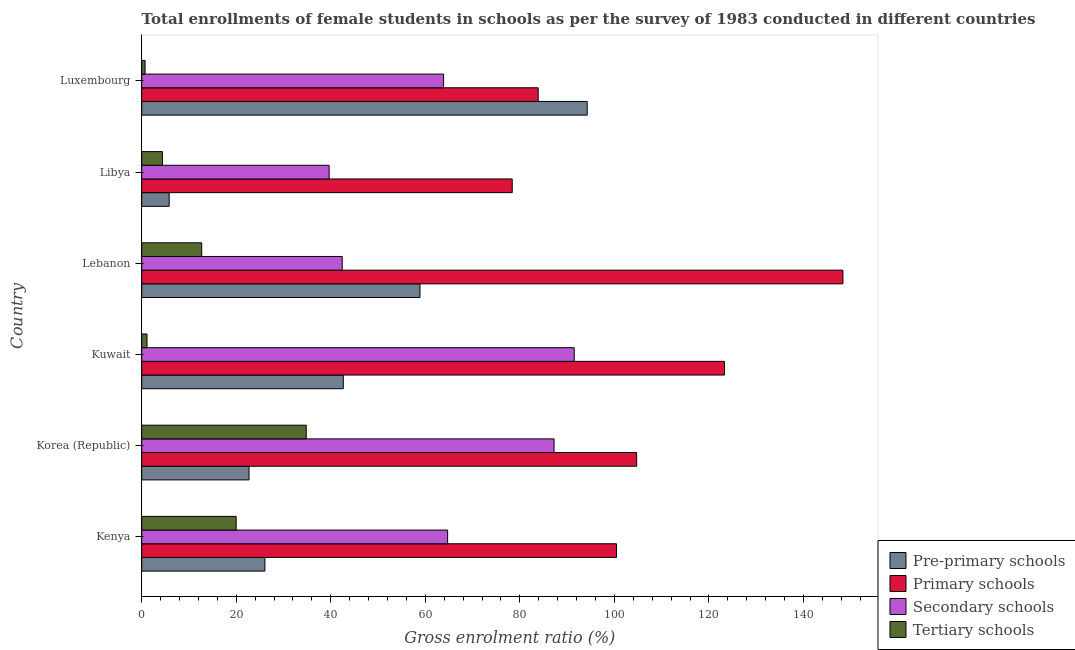How many groups of bars are there?
Your response must be concise. 6. Are the number of bars on each tick of the Y-axis equal?
Provide a short and direct response. Yes. How many bars are there on the 3rd tick from the top?
Keep it short and to the point. 4. What is the label of the 4th group of bars from the top?
Give a very brief answer. Kuwait. What is the gross enrolment ratio(female) in tertiary schools in Lebanon?
Your response must be concise. 12.69. Across all countries, what is the maximum gross enrolment ratio(female) in primary schools?
Provide a succinct answer. 148.33. Across all countries, what is the minimum gross enrolment ratio(female) in secondary schools?
Offer a terse response. 39.65. In which country was the gross enrolment ratio(female) in tertiary schools maximum?
Make the answer very short. Korea (Republic). In which country was the gross enrolment ratio(female) in primary schools minimum?
Ensure brevity in your answer.  Libya. What is the total gross enrolment ratio(female) in tertiary schools in the graph?
Your answer should be very brief. 73.69. What is the difference between the gross enrolment ratio(female) in primary schools in Korea (Republic) and that in Lebanon?
Ensure brevity in your answer.  -43.64. What is the difference between the gross enrolment ratio(female) in primary schools in Luxembourg and the gross enrolment ratio(female) in pre-primary schools in Kuwait?
Make the answer very short. 41.22. What is the average gross enrolment ratio(female) in pre-primary schools per country?
Make the answer very short. 41.72. What is the difference between the gross enrolment ratio(female) in pre-primary schools and gross enrolment ratio(female) in tertiary schools in Libya?
Give a very brief answer. 1.43. In how many countries, is the gross enrolment ratio(female) in primary schools greater than 120 %?
Make the answer very short. 2. What is the ratio of the gross enrolment ratio(female) in pre-primary schools in Kenya to that in Libya?
Provide a short and direct response. 4.49. Is the difference between the gross enrolment ratio(female) in tertiary schools in Kenya and Lebanon greater than the difference between the gross enrolment ratio(female) in pre-primary schools in Kenya and Lebanon?
Provide a succinct answer. Yes. What is the difference between the highest and the second highest gross enrolment ratio(female) in pre-primary schools?
Give a very brief answer. 35.38. What is the difference between the highest and the lowest gross enrolment ratio(female) in primary schools?
Offer a very short reply. 69.95. Is the sum of the gross enrolment ratio(female) in tertiary schools in Kuwait and Luxembourg greater than the maximum gross enrolment ratio(female) in pre-primary schools across all countries?
Make the answer very short. No. Is it the case that in every country, the sum of the gross enrolment ratio(female) in secondary schools and gross enrolment ratio(female) in pre-primary schools is greater than the sum of gross enrolment ratio(female) in primary schools and gross enrolment ratio(female) in tertiary schools?
Ensure brevity in your answer.  No. What does the 2nd bar from the top in Libya represents?
Your answer should be very brief. Secondary schools. What does the 2nd bar from the bottom in Luxembourg represents?
Give a very brief answer. Primary schools. Are all the bars in the graph horizontal?
Make the answer very short. Yes. Are the values on the major ticks of X-axis written in scientific E-notation?
Make the answer very short. No. How are the legend labels stacked?
Provide a short and direct response. Vertical. What is the title of the graph?
Your response must be concise. Total enrollments of female students in schools as per the survey of 1983 conducted in different countries. Does "PFC gas" appear as one of the legend labels in the graph?
Your response must be concise. No. What is the label or title of the X-axis?
Your answer should be very brief. Gross enrolment ratio (%). What is the Gross enrolment ratio (%) in Pre-primary schools in Kenya?
Your answer should be compact. 26.06. What is the Gross enrolment ratio (%) in Primary schools in Kenya?
Make the answer very short. 100.43. What is the Gross enrolment ratio (%) in Secondary schools in Kenya?
Ensure brevity in your answer.  64.71. What is the Gross enrolment ratio (%) of Tertiary schools in Kenya?
Ensure brevity in your answer.  19.98. What is the Gross enrolment ratio (%) in Pre-primary schools in Korea (Republic)?
Your response must be concise. 22.7. What is the Gross enrolment ratio (%) in Primary schools in Korea (Republic)?
Offer a terse response. 104.7. What is the Gross enrolment ratio (%) in Secondary schools in Korea (Republic)?
Offer a terse response. 87.23. What is the Gross enrolment ratio (%) of Tertiary schools in Korea (Republic)?
Give a very brief answer. 34.81. What is the Gross enrolment ratio (%) of Pre-primary schools in Kuwait?
Provide a succinct answer. 42.64. What is the Gross enrolment ratio (%) of Primary schools in Kuwait?
Offer a terse response. 123.27. What is the Gross enrolment ratio (%) in Secondary schools in Kuwait?
Provide a succinct answer. 91.49. What is the Gross enrolment ratio (%) in Tertiary schools in Kuwait?
Your response must be concise. 1.12. What is the Gross enrolment ratio (%) of Pre-primary schools in Lebanon?
Your response must be concise. 58.86. What is the Gross enrolment ratio (%) in Primary schools in Lebanon?
Provide a succinct answer. 148.33. What is the Gross enrolment ratio (%) of Secondary schools in Lebanon?
Offer a very short reply. 42.41. What is the Gross enrolment ratio (%) of Tertiary schools in Lebanon?
Give a very brief answer. 12.69. What is the Gross enrolment ratio (%) of Pre-primary schools in Libya?
Give a very brief answer. 5.81. What is the Gross enrolment ratio (%) of Primary schools in Libya?
Your answer should be very brief. 78.38. What is the Gross enrolment ratio (%) of Secondary schools in Libya?
Your response must be concise. 39.65. What is the Gross enrolment ratio (%) of Tertiary schools in Libya?
Your response must be concise. 4.38. What is the Gross enrolment ratio (%) in Pre-primary schools in Luxembourg?
Offer a very short reply. 94.24. What is the Gross enrolment ratio (%) of Primary schools in Luxembourg?
Your response must be concise. 83.87. What is the Gross enrolment ratio (%) in Secondary schools in Luxembourg?
Offer a very short reply. 63.86. What is the Gross enrolment ratio (%) of Tertiary schools in Luxembourg?
Keep it short and to the point. 0.71. Across all countries, what is the maximum Gross enrolment ratio (%) of Pre-primary schools?
Your answer should be very brief. 94.24. Across all countries, what is the maximum Gross enrolment ratio (%) of Primary schools?
Your answer should be very brief. 148.33. Across all countries, what is the maximum Gross enrolment ratio (%) in Secondary schools?
Offer a very short reply. 91.49. Across all countries, what is the maximum Gross enrolment ratio (%) in Tertiary schools?
Provide a succinct answer. 34.81. Across all countries, what is the minimum Gross enrolment ratio (%) of Pre-primary schools?
Give a very brief answer. 5.81. Across all countries, what is the minimum Gross enrolment ratio (%) in Primary schools?
Offer a very short reply. 78.38. Across all countries, what is the minimum Gross enrolment ratio (%) in Secondary schools?
Your response must be concise. 39.65. Across all countries, what is the minimum Gross enrolment ratio (%) of Tertiary schools?
Your answer should be compact. 0.71. What is the total Gross enrolment ratio (%) in Pre-primary schools in the graph?
Your answer should be compact. 250.31. What is the total Gross enrolment ratio (%) of Primary schools in the graph?
Your response must be concise. 638.98. What is the total Gross enrolment ratio (%) in Secondary schools in the graph?
Your answer should be compact. 389.35. What is the total Gross enrolment ratio (%) of Tertiary schools in the graph?
Your answer should be very brief. 73.69. What is the difference between the Gross enrolment ratio (%) in Pre-primary schools in Kenya and that in Korea (Republic)?
Offer a terse response. 3.36. What is the difference between the Gross enrolment ratio (%) of Primary schools in Kenya and that in Korea (Republic)?
Your answer should be very brief. -4.26. What is the difference between the Gross enrolment ratio (%) in Secondary schools in Kenya and that in Korea (Republic)?
Give a very brief answer. -22.52. What is the difference between the Gross enrolment ratio (%) in Tertiary schools in Kenya and that in Korea (Republic)?
Your answer should be compact. -14.83. What is the difference between the Gross enrolment ratio (%) in Pre-primary schools in Kenya and that in Kuwait?
Provide a succinct answer. -16.58. What is the difference between the Gross enrolment ratio (%) in Primary schools in Kenya and that in Kuwait?
Offer a very short reply. -22.84. What is the difference between the Gross enrolment ratio (%) in Secondary schools in Kenya and that in Kuwait?
Provide a short and direct response. -26.78. What is the difference between the Gross enrolment ratio (%) in Tertiary schools in Kenya and that in Kuwait?
Give a very brief answer. 18.86. What is the difference between the Gross enrolment ratio (%) of Pre-primary schools in Kenya and that in Lebanon?
Your response must be concise. -32.8. What is the difference between the Gross enrolment ratio (%) in Primary schools in Kenya and that in Lebanon?
Your answer should be very brief. -47.9. What is the difference between the Gross enrolment ratio (%) in Secondary schools in Kenya and that in Lebanon?
Offer a very short reply. 22.3. What is the difference between the Gross enrolment ratio (%) of Tertiary schools in Kenya and that in Lebanon?
Keep it short and to the point. 7.29. What is the difference between the Gross enrolment ratio (%) in Pre-primary schools in Kenya and that in Libya?
Offer a terse response. 20.25. What is the difference between the Gross enrolment ratio (%) of Primary schools in Kenya and that in Libya?
Keep it short and to the point. 22.05. What is the difference between the Gross enrolment ratio (%) in Secondary schools in Kenya and that in Libya?
Offer a very short reply. 25.06. What is the difference between the Gross enrolment ratio (%) of Tertiary schools in Kenya and that in Libya?
Keep it short and to the point. 15.6. What is the difference between the Gross enrolment ratio (%) of Pre-primary schools in Kenya and that in Luxembourg?
Your answer should be very brief. -68.18. What is the difference between the Gross enrolment ratio (%) in Primary schools in Kenya and that in Luxembourg?
Ensure brevity in your answer.  16.57. What is the difference between the Gross enrolment ratio (%) of Secondary schools in Kenya and that in Luxembourg?
Keep it short and to the point. 0.85. What is the difference between the Gross enrolment ratio (%) in Tertiary schools in Kenya and that in Luxembourg?
Make the answer very short. 19.27. What is the difference between the Gross enrolment ratio (%) in Pre-primary schools in Korea (Republic) and that in Kuwait?
Make the answer very short. -19.94. What is the difference between the Gross enrolment ratio (%) in Primary schools in Korea (Republic) and that in Kuwait?
Make the answer very short. -18.58. What is the difference between the Gross enrolment ratio (%) in Secondary schools in Korea (Republic) and that in Kuwait?
Keep it short and to the point. -4.26. What is the difference between the Gross enrolment ratio (%) in Tertiary schools in Korea (Republic) and that in Kuwait?
Offer a very short reply. 33.69. What is the difference between the Gross enrolment ratio (%) in Pre-primary schools in Korea (Republic) and that in Lebanon?
Keep it short and to the point. -36.16. What is the difference between the Gross enrolment ratio (%) of Primary schools in Korea (Republic) and that in Lebanon?
Give a very brief answer. -43.64. What is the difference between the Gross enrolment ratio (%) of Secondary schools in Korea (Republic) and that in Lebanon?
Make the answer very short. 44.81. What is the difference between the Gross enrolment ratio (%) in Tertiary schools in Korea (Republic) and that in Lebanon?
Offer a terse response. 22.11. What is the difference between the Gross enrolment ratio (%) in Pre-primary schools in Korea (Republic) and that in Libya?
Keep it short and to the point. 16.89. What is the difference between the Gross enrolment ratio (%) of Primary schools in Korea (Republic) and that in Libya?
Offer a very short reply. 26.32. What is the difference between the Gross enrolment ratio (%) in Secondary schools in Korea (Republic) and that in Libya?
Your answer should be compact. 47.58. What is the difference between the Gross enrolment ratio (%) of Tertiary schools in Korea (Republic) and that in Libya?
Give a very brief answer. 30.42. What is the difference between the Gross enrolment ratio (%) in Pre-primary schools in Korea (Republic) and that in Luxembourg?
Give a very brief answer. -71.54. What is the difference between the Gross enrolment ratio (%) in Primary schools in Korea (Republic) and that in Luxembourg?
Ensure brevity in your answer.  20.83. What is the difference between the Gross enrolment ratio (%) of Secondary schools in Korea (Republic) and that in Luxembourg?
Provide a succinct answer. 23.37. What is the difference between the Gross enrolment ratio (%) of Tertiary schools in Korea (Republic) and that in Luxembourg?
Give a very brief answer. 34.09. What is the difference between the Gross enrolment ratio (%) in Pre-primary schools in Kuwait and that in Lebanon?
Your response must be concise. -16.22. What is the difference between the Gross enrolment ratio (%) of Primary schools in Kuwait and that in Lebanon?
Give a very brief answer. -25.06. What is the difference between the Gross enrolment ratio (%) of Secondary schools in Kuwait and that in Lebanon?
Make the answer very short. 49.08. What is the difference between the Gross enrolment ratio (%) of Tertiary schools in Kuwait and that in Lebanon?
Provide a short and direct response. -11.57. What is the difference between the Gross enrolment ratio (%) of Pre-primary schools in Kuwait and that in Libya?
Your response must be concise. 36.83. What is the difference between the Gross enrolment ratio (%) in Primary schools in Kuwait and that in Libya?
Offer a terse response. 44.9. What is the difference between the Gross enrolment ratio (%) in Secondary schools in Kuwait and that in Libya?
Your answer should be very brief. 51.85. What is the difference between the Gross enrolment ratio (%) of Tertiary schools in Kuwait and that in Libya?
Make the answer very short. -3.27. What is the difference between the Gross enrolment ratio (%) in Pre-primary schools in Kuwait and that in Luxembourg?
Your answer should be compact. -51.6. What is the difference between the Gross enrolment ratio (%) in Primary schools in Kuwait and that in Luxembourg?
Your response must be concise. 39.41. What is the difference between the Gross enrolment ratio (%) of Secondary schools in Kuwait and that in Luxembourg?
Your response must be concise. 27.63. What is the difference between the Gross enrolment ratio (%) of Tertiary schools in Kuwait and that in Luxembourg?
Your response must be concise. 0.4. What is the difference between the Gross enrolment ratio (%) in Pre-primary schools in Lebanon and that in Libya?
Offer a very short reply. 53.05. What is the difference between the Gross enrolment ratio (%) of Primary schools in Lebanon and that in Libya?
Your response must be concise. 69.95. What is the difference between the Gross enrolment ratio (%) in Secondary schools in Lebanon and that in Libya?
Ensure brevity in your answer.  2.77. What is the difference between the Gross enrolment ratio (%) of Tertiary schools in Lebanon and that in Libya?
Offer a terse response. 8.31. What is the difference between the Gross enrolment ratio (%) of Pre-primary schools in Lebanon and that in Luxembourg?
Provide a succinct answer. -35.38. What is the difference between the Gross enrolment ratio (%) in Primary schools in Lebanon and that in Luxembourg?
Ensure brevity in your answer.  64.47. What is the difference between the Gross enrolment ratio (%) of Secondary schools in Lebanon and that in Luxembourg?
Provide a succinct answer. -21.44. What is the difference between the Gross enrolment ratio (%) of Tertiary schools in Lebanon and that in Luxembourg?
Give a very brief answer. 11.98. What is the difference between the Gross enrolment ratio (%) of Pre-primary schools in Libya and that in Luxembourg?
Your response must be concise. -88.43. What is the difference between the Gross enrolment ratio (%) in Primary schools in Libya and that in Luxembourg?
Make the answer very short. -5.49. What is the difference between the Gross enrolment ratio (%) in Secondary schools in Libya and that in Luxembourg?
Give a very brief answer. -24.21. What is the difference between the Gross enrolment ratio (%) in Tertiary schools in Libya and that in Luxembourg?
Provide a short and direct response. 3.67. What is the difference between the Gross enrolment ratio (%) of Pre-primary schools in Kenya and the Gross enrolment ratio (%) of Primary schools in Korea (Republic)?
Your answer should be very brief. -78.64. What is the difference between the Gross enrolment ratio (%) of Pre-primary schools in Kenya and the Gross enrolment ratio (%) of Secondary schools in Korea (Republic)?
Provide a succinct answer. -61.17. What is the difference between the Gross enrolment ratio (%) in Pre-primary schools in Kenya and the Gross enrolment ratio (%) in Tertiary schools in Korea (Republic)?
Your answer should be very brief. -8.75. What is the difference between the Gross enrolment ratio (%) of Primary schools in Kenya and the Gross enrolment ratio (%) of Secondary schools in Korea (Republic)?
Provide a short and direct response. 13.2. What is the difference between the Gross enrolment ratio (%) in Primary schools in Kenya and the Gross enrolment ratio (%) in Tertiary schools in Korea (Republic)?
Provide a short and direct response. 65.63. What is the difference between the Gross enrolment ratio (%) of Secondary schools in Kenya and the Gross enrolment ratio (%) of Tertiary schools in Korea (Republic)?
Your answer should be very brief. 29.9. What is the difference between the Gross enrolment ratio (%) of Pre-primary schools in Kenya and the Gross enrolment ratio (%) of Primary schools in Kuwait?
Provide a short and direct response. -97.22. What is the difference between the Gross enrolment ratio (%) of Pre-primary schools in Kenya and the Gross enrolment ratio (%) of Secondary schools in Kuwait?
Keep it short and to the point. -65.44. What is the difference between the Gross enrolment ratio (%) in Pre-primary schools in Kenya and the Gross enrolment ratio (%) in Tertiary schools in Kuwait?
Provide a succinct answer. 24.94. What is the difference between the Gross enrolment ratio (%) of Primary schools in Kenya and the Gross enrolment ratio (%) of Secondary schools in Kuwait?
Provide a short and direct response. 8.94. What is the difference between the Gross enrolment ratio (%) of Primary schools in Kenya and the Gross enrolment ratio (%) of Tertiary schools in Kuwait?
Make the answer very short. 99.32. What is the difference between the Gross enrolment ratio (%) of Secondary schools in Kenya and the Gross enrolment ratio (%) of Tertiary schools in Kuwait?
Your answer should be compact. 63.59. What is the difference between the Gross enrolment ratio (%) of Pre-primary schools in Kenya and the Gross enrolment ratio (%) of Primary schools in Lebanon?
Offer a very short reply. -122.28. What is the difference between the Gross enrolment ratio (%) of Pre-primary schools in Kenya and the Gross enrolment ratio (%) of Secondary schools in Lebanon?
Keep it short and to the point. -16.36. What is the difference between the Gross enrolment ratio (%) in Pre-primary schools in Kenya and the Gross enrolment ratio (%) in Tertiary schools in Lebanon?
Make the answer very short. 13.37. What is the difference between the Gross enrolment ratio (%) in Primary schools in Kenya and the Gross enrolment ratio (%) in Secondary schools in Lebanon?
Offer a very short reply. 58.02. What is the difference between the Gross enrolment ratio (%) in Primary schools in Kenya and the Gross enrolment ratio (%) in Tertiary schools in Lebanon?
Keep it short and to the point. 87.74. What is the difference between the Gross enrolment ratio (%) of Secondary schools in Kenya and the Gross enrolment ratio (%) of Tertiary schools in Lebanon?
Give a very brief answer. 52.02. What is the difference between the Gross enrolment ratio (%) of Pre-primary schools in Kenya and the Gross enrolment ratio (%) of Primary schools in Libya?
Ensure brevity in your answer.  -52.32. What is the difference between the Gross enrolment ratio (%) of Pre-primary schools in Kenya and the Gross enrolment ratio (%) of Secondary schools in Libya?
Provide a short and direct response. -13.59. What is the difference between the Gross enrolment ratio (%) in Pre-primary schools in Kenya and the Gross enrolment ratio (%) in Tertiary schools in Libya?
Your answer should be very brief. 21.68. What is the difference between the Gross enrolment ratio (%) of Primary schools in Kenya and the Gross enrolment ratio (%) of Secondary schools in Libya?
Provide a succinct answer. 60.78. What is the difference between the Gross enrolment ratio (%) in Primary schools in Kenya and the Gross enrolment ratio (%) in Tertiary schools in Libya?
Offer a very short reply. 96.05. What is the difference between the Gross enrolment ratio (%) in Secondary schools in Kenya and the Gross enrolment ratio (%) in Tertiary schools in Libya?
Your response must be concise. 60.33. What is the difference between the Gross enrolment ratio (%) in Pre-primary schools in Kenya and the Gross enrolment ratio (%) in Primary schools in Luxembourg?
Your response must be concise. -57.81. What is the difference between the Gross enrolment ratio (%) in Pre-primary schools in Kenya and the Gross enrolment ratio (%) in Secondary schools in Luxembourg?
Provide a succinct answer. -37.8. What is the difference between the Gross enrolment ratio (%) in Pre-primary schools in Kenya and the Gross enrolment ratio (%) in Tertiary schools in Luxembourg?
Ensure brevity in your answer.  25.34. What is the difference between the Gross enrolment ratio (%) of Primary schools in Kenya and the Gross enrolment ratio (%) of Secondary schools in Luxembourg?
Your response must be concise. 36.57. What is the difference between the Gross enrolment ratio (%) of Primary schools in Kenya and the Gross enrolment ratio (%) of Tertiary schools in Luxembourg?
Your answer should be very brief. 99.72. What is the difference between the Gross enrolment ratio (%) in Secondary schools in Kenya and the Gross enrolment ratio (%) in Tertiary schools in Luxembourg?
Your answer should be compact. 64. What is the difference between the Gross enrolment ratio (%) of Pre-primary schools in Korea (Republic) and the Gross enrolment ratio (%) of Primary schools in Kuwait?
Provide a short and direct response. -100.57. What is the difference between the Gross enrolment ratio (%) in Pre-primary schools in Korea (Republic) and the Gross enrolment ratio (%) in Secondary schools in Kuwait?
Your response must be concise. -68.79. What is the difference between the Gross enrolment ratio (%) of Pre-primary schools in Korea (Republic) and the Gross enrolment ratio (%) of Tertiary schools in Kuwait?
Keep it short and to the point. 21.59. What is the difference between the Gross enrolment ratio (%) in Primary schools in Korea (Republic) and the Gross enrolment ratio (%) in Secondary schools in Kuwait?
Provide a succinct answer. 13.2. What is the difference between the Gross enrolment ratio (%) in Primary schools in Korea (Republic) and the Gross enrolment ratio (%) in Tertiary schools in Kuwait?
Provide a short and direct response. 103.58. What is the difference between the Gross enrolment ratio (%) of Secondary schools in Korea (Republic) and the Gross enrolment ratio (%) of Tertiary schools in Kuwait?
Offer a terse response. 86.11. What is the difference between the Gross enrolment ratio (%) in Pre-primary schools in Korea (Republic) and the Gross enrolment ratio (%) in Primary schools in Lebanon?
Provide a short and direct response. -125.63. What is the difference between the Gross enrolment ratio (%) of Pre-primary schools in Korea (Republic) and the Gross enrolment ratio (%) of Secondary schools in Lebanon?
Offer a terse response. -19.71. What is the difference between the Gross enrolment ratio (%) of Pre-primary schools in Korea (Republic) and the Gross enrolment ratio (%) of Tertiary schools in Lebanon?
Provide a short and direct response. 10.01. What is the difference between the Gross enrolment ratio (%) of Primary schools in Korea (Republic) and the Gross enrolment ratio (%) of Secondary schools in Lebanon?
Your answer should be compact. 62.28. What is the difference between the Gross enrolment ratio (%) of Primary schools in Korea (Republic) and the Gross enrolment ratio (%) of Tertiary schools in Lebanon?
Ensure brevity in your answer.  92.01. What is the difference between the Gross enrolment ratio (%) in Secondary schools in Korea (Republic) and the Gross enrolment ratio (%) in Tertiary schools in Lebanon?
Provide a succinct answer. 74.54. What is the difference between the Gross enrolment ratio (%) of Pre-primary schools in Korea (Republic) and the Gross enrolment ratio (%) of Primary schools in Libya?
Ensure brevity in your answer.  -55.68. What is the difference between the Gross enrolment ratio (%) in Pre-primary schools in Korea (Republic) and the Gross enrolment ratio (%) in Secondary schools in Libya?
Your answer should be very brief. -16.95. What is the difference between the Gross enrolment ratio (%) in Pre-primary schools in Korea (Republic) and the Gross enrolment ratio (%) in Tertiary schools in Libya?
Offer a terse response. 18.32. What is the difference between the Gross enrolment ratio (%) in Primary schools in Korea (Republic) and the Gross enrolment ratio (%) in Secondary schools in Libya?
Keep it short and to the point. 65.05. What is the difference between the Gross enrolment ratio (%) of Primary schools in Korea (Republic) and the Gross enrolment ratio (%) of Tertiary schools in Libya?
Keep it short and to the point. 100.31. What is the difference between the Gross enrolment ratio (%) in Secondary schools in Korea (Republic) and the Gross enrolment ratio (%) in Tertiary schools in Libya?
Keep it short and to the point. 82.85. What is the difference between the Gross enrolment ratio (%) of Pre-primary schools in Korea (Republic) and the Gross enrolment ratio (%) of Primary schools in Luxembourg?
Offer a very short reply. -61.16. What is the difference between the Gross enrolment ratio (%) of Pre-primary schools in Korea (Republic) and the Gross enrolment ratio (%) of Secondary schools in Luxembourg?
Give a very brief answer. -41.16. What is the difference between the Gross enrolment ratio (%) of Pre-primary schools in Korea (Republic) and the Gross enrolment ratio (%) of Tertiary schools in Luxembourg?
Give a very brief answer. 21.99. What is the difference between the Gross enrolment ratio (%) of Primary schools in Korea (Republic) and the Gross enrolment ratio (%) of Secondary schools in Luxembourg?
Provide a succinct answer. 40.84. What is the difference between the Gross enrolment ratio (%) of Primary schools in Korea (Republic) and the Gross enrolment ratio (%) of Tertiary schools in Luxembourg?
Make the answer very short. 103.98. What is the difference between the Gross enrolment ratio (%) of Secondary schools in Korea (Republic) and the Gross enrolment ratio (%) of Tertiary schools in Luxembourg?
Offer a very short reply. 86.52. What is the difference between the Gross enrolment ratio (%) in Pre-primary schools in Kuwait and the Gross enrolment ratio (%) in Primary schools in Lebanon?
Give a very brief answer. -105.69. What is the difference between the Gross enrolment ratio (%) in Pre-primary schools in Kuwait and the Gross enrolment ratio (%) in Secondary schools in Lebanon?
Ensure brevity in your answer.  0.23. What is the difference between the Gross enrolment ratio (%) in Pre-primary schools in Kuwait and the Gross enrolment ratio (%) in Tertiary schools in Lebanon?
Give a very brief answer. 29.95. What is the difference between the Gross enrolment ratio (%) of Primary schools in Kuwait and the Gross enrolment ratio (%) of Secondary schools in Lebanon?
Keep it short and to the point. 80.86. What is the difference between the Gross enrolment ratio (%) in Primary schools in Kuwait and the Gross enrolment ratio (%) in Tertiary schools in Lebanon?
Provide a short and direct response. 110.58. What is the difference between the Gross enrolment ratio (%) in Secondary schools in Kuwait and the Gross enrolment ratio (%) in Tertiary schools in Lebanon?
Provide a short and direct response. 78.8. What is the difference between the Gross enrolment ratio (%) of Pre-primary schools in Kuwait and the Gross enrolment ratio (%) of Primary schools in Libya?
Your response must be concise. -35.74. What is the difference between the Gross enrolment ratio (%) in Pre-primary schools in Kuwait and the Gross enrolment ratio (%) in Secondary schools in Libya?
Your answer should be very brief. 2.99. What is the difference between the Gross enrolment ratio (%) in Pre-primary schools in Kuwait and the Gross enrolment ratio (%) in Tertiary schools in Libya?
Your response must be concise. 38.26. What is the difference between the Gross enrolment ratio (%) in Primary schools in Kuwait and the Gross enrolment ratio (%) in Secondary schools in Libya?
Your answer should be very brief. 83.63. What is the difference between the Gross enrolment ratio (%) in Primary schools in Kuwait and the Gross enrolment ratio (%) in Tertiary schools in Libya?
Ensure brevity in your answer.  118.89. What is the difference between the Gross enrolment ratio (%) of Secondary schools in Kuwait and the Gross enrolment ratio (%) of Tertiary schools in Libya?
Give a very brief answer. 87.11. What is the difference between the Gross enrolment ratio (%) of Pre-primary schools in Kuwait and the Gross enrolment ratio (%) of Primary schools in Luxembourg?
Your answer should be very brief. -41.22. What is the difference between the Gross enrolment ratio (%) of Pre-primary schools in Kuwait and the Gross enrolment ratio (%) of Secondary schools in Luxembourg?
Your answer should be very brief. -21.22. What is the difference between the Gross enrolment ratio (%) in Pre-primary schools in Kuwait and the Gross enrolment ratio (%) in Tertiary schools in Luxembourg?
Your answer should be very brief. 41.93. What is the difference between the Gross enrolment ratio (%) in Primary schools in Kuwait and the Gross enrolment ratio (%) in Secondary schools in Luxembourg?
Your response must be concise. 59.42. What is the difference between the Gross enrolment ratio (%) in Primary schools in Kuwait and the Gross enrolment ratio (%) in Tertiary schools in Luxembourg?
Offer a very short reply. 122.56. What is the difference between the Gross enrolment ratio (%) of Secondary schools in Kuwait and the Gross enrolment ratio (%) of Tertiary schools in Luxembourg?
Give a very brief answer. 90.78. What is the difference between the Gross enrolment ratio (%) of Pre-primary schools in Lebanon and the Gross enrolment ratio (%) of Primary schools in Libya?
Offer a terse response. -19.52. What is the difference between the Gross enrolment ratio (%) of Pre-primary schools in Lebanon and the Gross enrolment ratio (%) of Secondary schools in Libya?
Provide a succinct answer. 19.21. What is the difference between the Gross enrolment ratio (%) in Pre-primary schools in Lebanon and the Gross enrolment ratio (%) in Tertiary schools in Libya?
Give a very brief answer. 54.48. What is the difference between the Gross enrolment ratio (%) in Primary schools in Lebanon and the Gross enrolment ratio (%) in Secondary schools in Libya?
Offer a very short reply. 108.69. What is the difference between the Gross enrolment ratio (%) of Primary schools in Lebanon and the Gross enrolment ratio (%) of Tertiary schools in Libya?
Your answer should be compact. 143.95. What is the difference between the Gross enrolment ratio (%) of Secondary schools in Lebanon and the Gross enrolment ratio (%) of Tertiary schools in Libya?
Provide a short and direct response. 38.03. What is the difference between the Gross enrolment ratio (%) in Pre-primary schools in Lebanon and the Gross enrolment ratio (%) in Primary schools in Luxembourg?
Your answer should be compact. -25. What is the difference between the Gross enrolment ratio (%) of Pre-primary schools in Lebanon and the Gross enrolment ratio (%) of Secondary schools in Luxembourg?
Keep it short and to the point. -5. What is the difference between the Gross enrolment ratio (%) in Pre-primary schools in Lebanon and the Gross enrolment ratio (%) in Tertiary schools in Luxembourg?
Your response must be concise. 58.15. What is the difference between the Gross enrolment ratio (%) of Primary schools in Lebanon and the Gross enrolment ratio (%) of Secondary schools in Luxembourg?
Make the answer very short. 84.47. What is the difference between the Gross enrolment ratio (%) of Primary schools in Lebanon and the Gross enrolment ratio (%) of Tertiary schools in Luxembourg?
Make the answer very short. 147.62. What is the difference between the Gross enrolment ratio (%) of Secondary schools in Lebanon and the Gross enrolment ratio (%) of Tertiary schools in Luxembourg?
Provide a succinct answer. 41.7. What is the difference between the Gross enrolment ratio (%) in Pre-primary schools in Libya and the Gross enrolment ratio (%) in Primary schools in Luxembourg?
Provide a short and direct response. -78.06. What is the difference between the Gross enrolment ratio (%) in Pre-primary schools in Libya and the Gross enrolment ratio (%) in Secondary schools in Luxembourg?
Give a very brief answer. -58.05. What is the difference between the Gross enrolment ratio (%) of Pre-primary schools in Libya and the Gross enrolment ratio (%) of Tertiary schools in Luxembourg?
Ensure brevity in your answer.  5.1. What is the difference between the Gross enrolment ratio (%) in Primary schools in Libya and the Gross enrolment ratio (%) in Secondary schools in Luxembourg?
Offer a very short reply. 14.52. What is the difference between the Gross enrolment ratio (%) of Primary schools in Libya and the Gross enrolment ratio (%) of Tertiary schools in Luxembourg?
Your answer should be very brief. 77.66. What is the difference between the Gross enrolment ratio (%) of Secondary schools in Libya and the Gross enrolment ratio (%) of Tertiary schools in Luxembourg?
Provide a succinct answer. 38.93. What is the average Gross enrolment ratio (%) in Pre-primary schools per country?
Your answer should be very brief. 41.72. What is the average Gross enrolment ratio (%) of Primary schools per country?
Your response must be concise. 106.5. What is the average Gross enrolment ratio (%) of Secondary schools per country?
Your response must be concise. 64.89. What is the average Gross enrolment ratio (%) in Tertiary schools per country?
Make the answer very short. 12.28. What is the difference between the Gross enrolment ratio (%) of Pre-primary schools and Gross enrolment ratio (%) of Primary schools in Kenya?
Ensure brevity in your answer.  -74.37. What is the difference between the Gross enrolment ratio (%) of Pre-primary schools and Gross enrolment ratio (%) of Secondary schools in Kenya?
Offer a terse response. -38.65. What is the difference between the Gross enrolment ratio (%) of Pre-primary schools and Gross enrolment ratio (%) of Tertiary schools in Kenya?
Ensure brevity in your answer.  6.08. What is the difference between the Gross enrolment ratio (%) of Primary schools and Gross enrolment ratio (%) of Secondary schools in Kenya?
Ensure brevity in your answer.  35.72. What is the difference between the Gross enrolment ratio (%) in Primary schools and Gross enrolment ratio (%) in Tertiary schools in Kenya?
Offer a terse response. 80.45. What is the difference between the Gross enrolment ratio (%) of Secondary schools and Gross enrolment ratio (%) of Tertiary schools in Kenya?
Make the answer very short. 44.73. What is the difference between the Gross enrolment ratio (%) in Pre-primary schools and Gross enrolment ratio (%) in Primary schools in Korea (Republic)?
Offer a very short reply. -81.99. What is the difference between the Gross enrolment ratio (%) of Pre-primary schools and Gross enrolment ratio (%) of Secondary schools in Korea (Republic)?
Make the answer very short. -64.53. What is the difference between the Gross enrolment ratio (%) in Pre-primary schools and Gross enrolment ratio (%) in Tertiary schools in Korea (Republic)?
Ensure brevity in your answer.  -12.1. What is the difference between the Gross enrolment ratio (%) in Primary schools and Gross enrolment ratio (%) in Secondary schools in Korea (Republic)?
Your answer should be compact. 17.47. What is the difference between the Gross enrolment ratio (%) in Primary schools and Gross enrolment ratio (%) in Tertiary schools in Korea (Republic)?
Your answer should be compact. 69.89. What is the difference between the Gross enrolment ratio (%) of Secondary schools and Gross enrolment ratio (%) of Tertiary schools in Korea (Republic)?
Make the answer very short. 52.42. What is the difference between the Gross enrolment ratio (%) of Pre-primary schools and Gross enrolment ratio (%) of Primary schools in Kuwait?
Your response must be concise. -80.63. What is the difference between the Gross enrolment ratio (%) in Pre-primary schools and Gross enrolment ratio (%) in Secondary schools in Kuwait?
Your answer should be compact. -48.85. What is the difference between the Gross enrolment ratio (%) of Pre-primary schools and Gross enrolment ratio (%) of Tertiary schools in Kuwait?
Ensure brevity in your answer.  41.53. What is the difference between the Gross enrolment ratio (%) in Primary schools and Gross enrolment ratio (%) in Secondary schools in Kuwait?
Provide a succinct answer. 31.78. What is the difference between the Gross enrolment ratio (%) of Primary schools and Gross enrolment ratio (%) of Tertiary schools in Kuwait?
Make the answer very short. 122.16. What is the difference between the Gross enrolment ratio (%) of Secondary schools and Gross enrolment ratio (%) of Tertiary schools in Kuwait?
Give a very brief answer. 90.38. What is the difference between the Gross enrolment ratio (%) in Pre-primary schools and Gross enrolment ratio (%) in Primary schools in Lebanon?
Give a very brief answer. -89.47. What is the difference between the Gross enrolment ratio (%) in Pre-primary schools and Gross enrolment ratio (%) in Secondary schools in Lebanon?
Ensure brevity in your answer.  16.45. What is the difference between the Gross enrolment ratio (%) in Pre-primary schools and Gross enrolment ratio (%) in Tertiary schools in Lebanon?
Give a very brief answer. 46.17. What is the difference between the Gross enrolment ratio (%) in Primary schools and Gross enrolment ratio (%) in Secondary schools in Lebanon?
Keep it short and to the point. 105.92. What is the difference between the Gross enrolment ratio (%) in Primary schools and Gross enrolment ratio (%) in Tertiary schools in Lebanon?
Make the answer very short. 135.64. What is the difference between the Gross enrolment ratio (%) of Secondary schools and Gross enrolment ratio (%) of Tertiary schools in Lebanon?
Offer a very short reply. 29.72. What is the difference between the Gross enrolment ratio (%) of Pre-primary schools and Gross enrolment ratio (%) of Primary schools in Libya?
Provide a succinct answer. -72.57. What is the difference between the Gross enrolment ratio (%) in Pre-primary schools and Gross enrolment ratio (%) in Secondary schools in Libya?
Ensure brevity in your answer.  -33.84. What is the difference between the Gross enrolment ratio (%) in Pre-primary schools and Gross enrolment ratio (%) in Tertiary schools in Libya?
Your answer should be very brief. 1.43. What is the difference between the Gross enrolment ratio (%) of Primary schools and Gross enrolment ratio (%) of Secondary schools in Libya?
Give a very brief answer. 38.73. What is the difference between the Gross enrolment ratio (%) in Primary schools and Gross enrolment ratio (%) in Tertiary schools in Libya?
Your answer should be very brief. 74. What is the difference between the Gross enrolment ratio (%) of Secondary schools and Gross enrolment ratio (%) of Tertiary schools in Libya?
Offer a very short reply. 35.27. What is the difference between the Gross enrolment ratio (%) of Pre-primary schools and Gross enrolment ratio (%) of Primary schools in Luxembourg?
Your response must be concise. 10.37. What is the difference between the Gross enrolment ratio (%) in Pre-primary schools and Gross enrolment ratio (%) in Secondary schools in Luxembourg?
Offer a terse response. 30.38. What is the difference between the Gross enrolment ratio (%) in Pre-primary schools and Gross enrolment ratio (%) in Tertiary schools in Luxembourg?
Provide a short and direct response. 93.52. What is the difference between the Gross enrolment ratio (%) of Primary schools and Gross enrolment ratio (%) of Secondary schools in Luxembourg?
Ensure brevity in your answer.  20.01. What is the difference between the Gross enrolment ratio (%) in Primary schools and Gross enrolment ratio (%) in Tertiary schools in Luxembourg?
Your response must be concise. 83.15. What is the difference between the Gross enrolment ratio (%) of Secondary schools and Gross enrolment ratio (%) of Tertiary schools in Luxembourg?
Keep it short and to the point. 63.14. What is the ratio of the Gross enrolment ratio (%) in Pre-primary schools in Kenya to that in Korea (Republic)?
Your response must be concise. 1.15. What is the ratio of the Gross enrolment ratio (%) of Primary schools in Kenya to that in Korea (Republic)?
Give a very brief answer. 0.96. What is the ratio of the Gross enrolment ratio (%) of Secondary schools in Kenya to that in Korea (Republic)?
Provide a short and direct response. 0.74. What is the ratio of the Gross enrolment ratio (%) in Tertiary schools in Kenya to that in Korea (Republic)?
Offer a very short reply. 0.57. What is the ratio of the Gross enrolment ratio (%) in Pre-primary schools in Kenya to that in Kuwait?
Provide a short and direct response. 0.61. What is the ratio of the Gross enrolment ratio (%) of Primary schools in Kenya to that in Kuwait?
Your answer should be compact. 0.81. What is the ratio of the Gross enrolment ratio (%) in Secondary schools in Kenya to that in Kuwait?
Your answer should be compact. 0.71. What is the ratio of the Gross enrolment ratio (%) in Tertiary schools in Kenya to that in Kuwait?
Offer a very short reply. 17.89. What is the ratio of the Gross enrolment ratio (%) of Pre-primary schools in Kenya to that in Lebanon?
Your response must be concise. 0.44. What is the ratio of the Gross enrolment ratio (%) of Primary schools in Kenya to that in Lebanon?
Your response must be concise. 0.68. What is the ratio of the Gross enrolment ratio (%) of Secondary schools in Kenya to that in Lebanon?
Make the answer very short. 1.53. What is the ratio of the Gross enrolment ratio (%) in Tertiary schools in Kenya to that in Lebanon?
Your response must be concise. 1.57. What is the ratio of the Gross enrolment ratio (%) in Pre-primary schools in Kenya to that in Libya?
Give a very brief answer. 4.49. What is the ratio of the Gross enrolment ratio (%) of Primary schools in Kenya to that in Libya?
Offer a very short reply. 1.28. What is the ratio of the Gross enrolment ratio (%) of Secondary schools in Kenya to that in Libya?
Give a very brief answer. 1.63. What is the ratio of the Gross enrolment ratio (%) of Tertiary schools in Kenya to that in Libya?
Give a very brief answer. 4.56. What is the ratio of the Gross enrolment ratio (%) of Pre-primary schools in Kenya to that in Luxembourg?
Provide a succinct answer. 0.28. What is the ratio of the Gross enrolment ratio (%) of Primary schools in Kenya to that in Luxembourg?
Give a very brief answer. 1.2. What is the ratio of the Gross enrolment ratio (%) of Secondary schools in Kenya to that in Luxembourg?
Give a very brief answer. 1.01. What is the ratio of the Gross enrolment ratio (%) of Tertiary schools in Kenya to that in Luxembourg?
Your answer should be compact. 27.99. What is the ratio of the Gross enrolment ratio (%) in Pre-primary schools in Korea (Republic) to that in Kuwait?
Your answer should be compact. 0.53. What is the ratio of the Gross enrolment ratio (%) of Primary schools in Korea (Republic) to that in Kuwait?
Make the answer very short. 0.85. What is the ratio of the Gross enrolment ratio (%) in Secondary schools in Korea (Republic) to that in Kuwait?
Ensure brevity in your answer.  0.95. What is the ratio of the Gross enrolment ratio (%) of Tertiary schools in Korea (Republic) to that in Kuwait?
Offer a very short reply. 31.17. What is the ratio of the Gross enrolment ratio (%) in Pre-primary schools in Korea (Republic) to that in Lebanon?
Make the answer very short. 0.39. What is the ratio of the Gross enrolment ratio (%) in Primary schools in Korea (Republic) to that in Lebanon?
Your response must be concise. 0.71. What is the ratio of the Gross enrolment ratio (%) in Secondary schools in Korea (Republic) to that in Lebanon?
Give a very brief answer. 2.06. What is the ratio of the Gross enrolment ratio (%) of Tertiary schools in Korea (Republic) to that in Lebanon?
Keep it short and to the point. 2.74. What is the ratio of the Gross enrolment ratio (%) of Pre-primary schools in Korea (Republic) to that in Libya?
Keep it short and to the point. 3.91. What is the ratio of the Gross enrolment ratio (%) of Primary schools in Korea (Republic) to that in Libya?
Offer a terse response. 1.34. What is the ratio of the Gross enrolment ratio (%) of Secondary schools in Korea (Republic) to that in Libya?
Your response must be concise. 2.2. What is the ratio of the Gross enrolment ratio (%) of Tertiary schools in Korea (Republic) to that in Libya?
Offer a terse response. 7.94. What is the ratio of the Gross enrolment ratio (%) in Pre-primary schools in Korea (Republic) to that in Luxembourg?
Make the answer very short. 0.24. What is the ratio of the Gross enrolment ratio (%) of Primary schools in Korea (Republic) to that in Luxembourg?
Offer a terse response. 1.25. What is the ratio of the Gross enrolment ratio (%) of Secondary schools in Korea (Republic) to that in Luxembourg?
Your answer should be compact. 1.37. What is the ratio of the Gross enrolment ratio (%) of Tertiary schools in Korea (Republic) to that in Luxembourg?
Your response must be concise. 48.75. What is the ratio of the Gross enrolment ratio (%) in Pre-primary schools in Kuwait to that in Lebanon?
Offer a terse response. 0.72. What is the ratio of the Gross enrolment ratio (%) of Primary schools in Kuwait to that in Lebanon?
Your response must be concise. 0.83. What is the ratio of the Gross enrolment ratio (%) in Secondary schools in Kuwait to that in Lebanon?
Keep it short and to the point. 2.16. What is the ratio of the Gross enrolment ratio (%) of Tertiary schools in Kuwait to that in Lebanon?
Ensure brevity in your answer.  0.09. What is the ratio of the Gross enrolment ratio (%) in Pre-primary schools in Kuwait to that in Libya?
Give a very brief answer. 7.34. What is the ratio of the Gross enrolment ratio (%) of Primary schools in Kuwait to that in Libya?
Your answer should be compact. 1.57. What is the ratio of the Gross enrolment ratio (%) of Secondary schools in Kuwait to that in Libya?
Offer a very short reply. 2.31. What is the ratio of the Gross enrolment ratio (%) in Tertiary schools in Kuwait to that in Libya?
Give a very brief answer. 0.25. What is the ratio of the Gross enrolment ratio (%) of Pre-primary schools in Kuwait to that in Luxembourg?
Offer a very short reply. 0.45. What is the ratio of the Gross enrolment ratio (%) in Primary schools in Kuwait to that in Luxembourg?
Your answer should be very brief. 1.47. What is the ratio of the Gross enrolment ratio (%) in Secondary schools in Kuwait to that in Luxembourg?
Your answer should be compact. 1.43. What is the ratio of the Gross enrolment ratio (%) in Tertiary schools in Kuwait to that in Luxembourg?
Give a very brief answer. 1.56. What is the ratio of the Gross enrolment ratio (%) in Pre-primary schools in Lebanon to that in Libya?
Provide a succinct answer. 10.13. What is the ratio of the Gross enrolment ratio (%) in Primary schools in Lebanon to that in Libya?
Your answer should be compact. 1.89. What is the ratio of the Gross enrolment ratio (%) in Secondary schools in Lebanon to that in Libya?
Your answer should be very brief. 1.07. What is the ratio of the Gross enrolment ratio (%) of Tertiary schools in Lebanon to that in Libya?
Provide a short and direct response. 2.9. What is the ratio of the Gross enrolment ratio (%) of Pre-primary schools in Lebanon to that in Luxembourg?
Ensure brevity in your answer.  0.62. What is the ratio of the Gross enrolment ratio (%) in Primary schools in Lebanon to that in Luxembourg?
Give a very brief answer. 1.77. What is the ratio of the Gross enrolment ratio (%) of Secondary schools in Lebanon to that in Luxembourg?
Keep it short and to the point. 0.66. What is the ratio of the Gross enrolment ratio (%) in Tertiary schools in Lebanon to that in Luxembourg?
Give a very brief answer. 17.78. What is the ratio of the Gross enrolment ratio (%) of Pre-primary schools in Libya to that in Luxembourg?
Your answer should be very brief. 0.06. What is the ratio of the Gross enrolment ratio (%) of Primary schools in Libya to that in Luxembourg?
Ensure brevity in your answer.  0.93. What is the ratio of the Gross enrolment ratio (%) of Secondary schools in Libya to that in Luxembourg?
Provide a succinct answer. 0.62. What is the ratio of the Gross enrolment ratio (%) of Tertiary schools in Libya to that in Luxembourg?
Provide a short and direct response. 6.14. What is the difference between the highest and the second highest Gross enrolment ratio (%) in Pre-primary schools?
Your answer should be compact. 35.38. What is the difference between the highest and the second highest Gross enrolment ratio (%) in Primary schools?
Provide a succinct answer. 25.06. What is the difference between the highest and the second highest Gross enrolment ratio (%) in Secondary schools?
Your answer should be compact. 4.26. What is the difference between the highest and the second highest Gross enrolment ratio (%) of Tertiary schools?
Provide a short and direct response. 14.83. What is the difference between the highest and the lowest Gross enrolment ratio (%) of Pre-primary schools?
Give a very brief answer. 88.43. What is the difference between the highest and the lowest Gross enrolment ratio (%) in Primary schools?
Your answer should be very brief. 69.95. What is the difference between the highest and the lowest Gross enrolment ratio (%) in Secondary schools?
Ensure brevity in your answer.  51.85. What is the difference between the highest and the lowest Gross enrolment ratio (%) of Tertiary schools?
Offer a terse response. 34.09. 